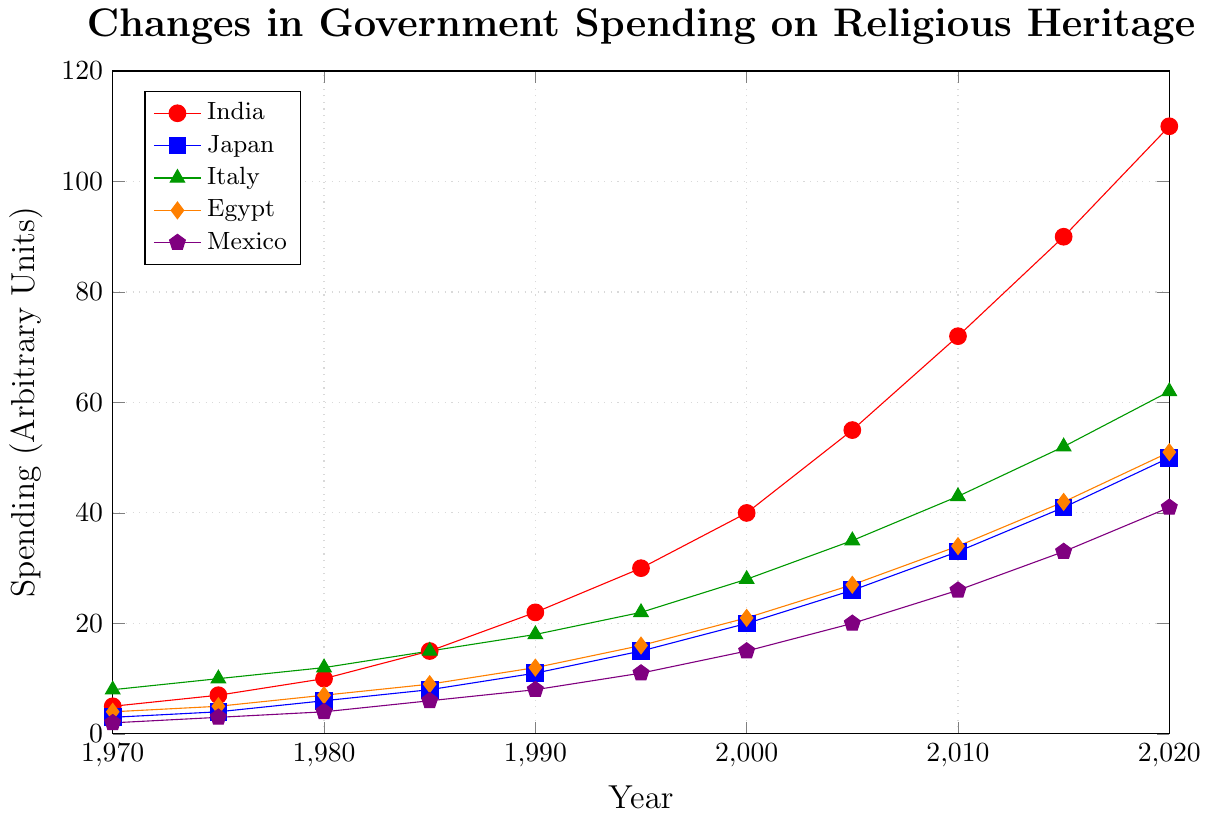Which country has the highest government spending on preserving religious heritage sites and supporting traditional festivals in 2020? India has the highest spending in 2020. The data shows India’s spending at 110, which is higher than all other countries in the same year.
Answer: India How did Japan's government spending change from 1970 to 2020? To find the change, subtract the 1970 value from the 2020 value for Japan. The values are 50 in 2020 and 3 in 1970. The change is 50 - 3 = 47.
Answer: Increased by 47 What is the average government spending on religious heritage and festivals in Mexico over the given years? Sum the spending values for Mexico and divide by the number of years. The values are 2, 3, 4, 6, 8, 11, 15, 20, 26, 33, 41. Sum = 169. There are 11 years: 169 / 11 ≈ 15.36.
Answer: Approximately 15.36 Between which two consecutive years did Italy see the highest increase in spending? Calculate the difference year by year and find the maximum difference: 1970-75 (2), 1975-80 (2), 1980-85 (3), 1985-90 (3), 1990-95 (4), 1995-2000 (6), 2000-05 (7), 2005-10 (8), 2010-15 (9), 2015-20 (10). The highest increase is from 2015 to 2020 with 10 units.
Answer: 2015 to 2020 By how much did Egypt's spending increase from 1980 to 1990? Subtract the 1980 spending from the 1990 spending for Egypt. The values are 12 in 1990 and 7 in 1980. The increase is 12 - 7 = 5.
Answer: Increased by 5 Which country had the lowest spending in 1970, and how much was it? By observing the values for 1970, Mexico has the lowest spending at 2.
Answer: Mexico, 2 What is the total increase in spending for India from 1970 to 2020? Subtract the 1970 value from the 2020 value for India. The values are 110 in 2020 and 5 in 1970. The increase is 110 - 5 = 105.
Answer: Increased by 105 Which country's spending grew the fastest between 2000 and 2010? Calculate the differences: India (72-40=32), Japan (33-20=13), Italy (43-28=15), Egypt (34-21=13), Mexico (26-15=11). India has the highest growth of 32.
Answer: India In which year did Egypt and Italy first reach a spending of 20 or more? For Egypt, starting from the dataset: it reaches 21 in 2000. For Italy, it reaches 22 in 1995. Egypt: 2000, Italy: 1995.
Answer: Egypt: 2000, Italy: 1995 